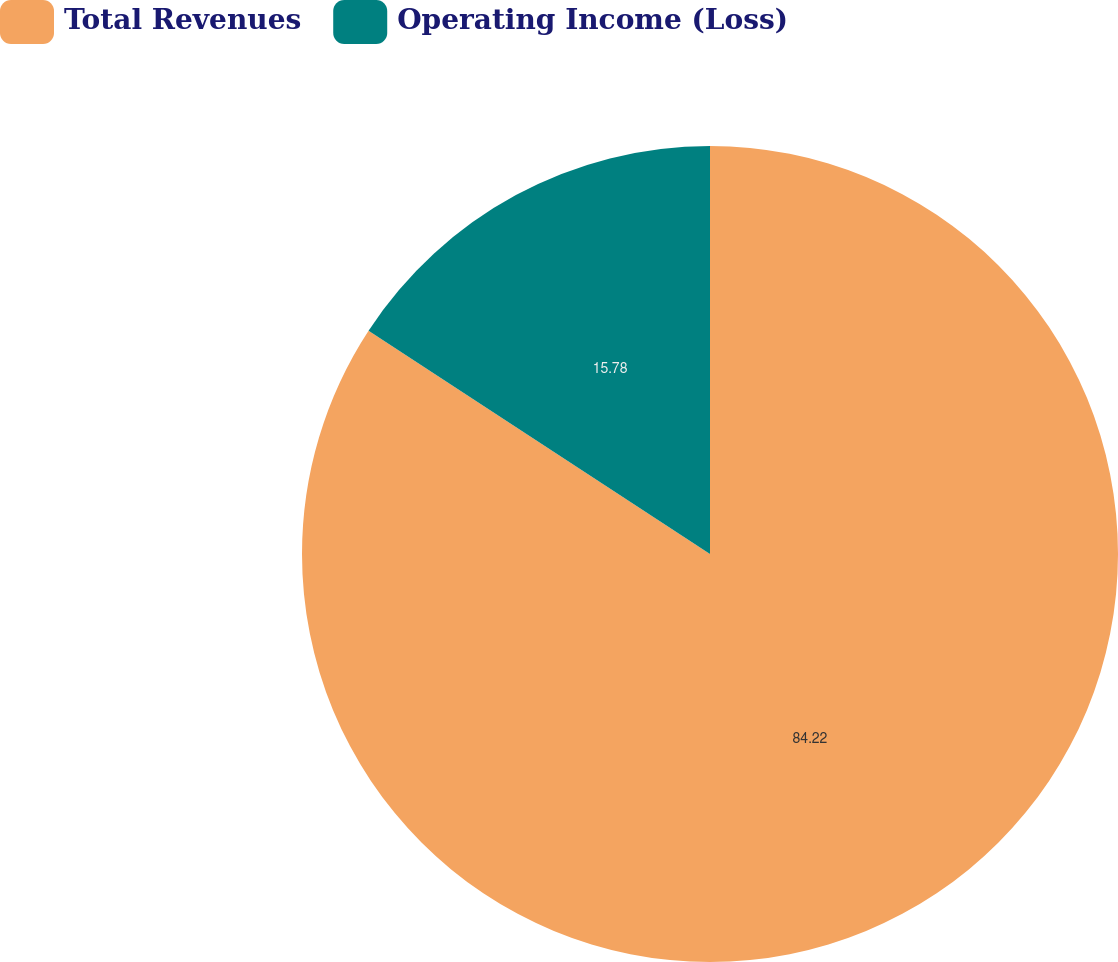Convert chart to OTSL. <chart><loc_0><loc_0><loc_500><loc_500><pie_chart><fcel>Total Revenues<fcel>Operating Income (Loss)<nl><fcel>84.22%<fcel>15.78%<nl></chart> 